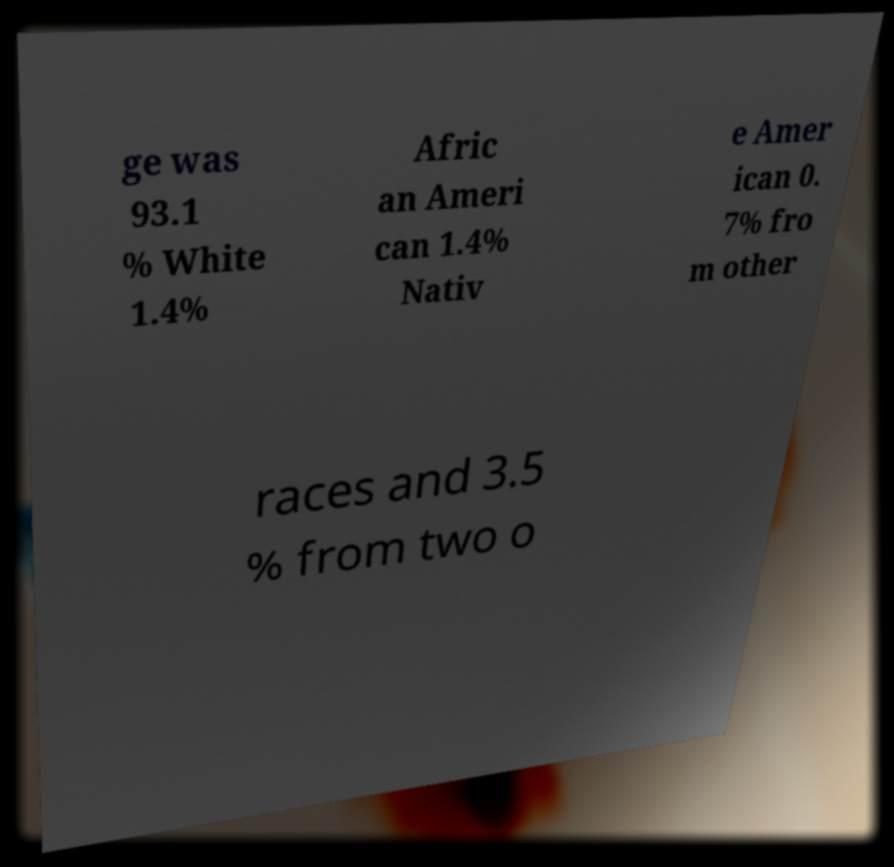I need the written content from this picture converted into text. Can you do that? ge was 93.1 % White 1.4% Afric an Ameri can 1.4% Nativ e Amer ican 0. 7% fro m other races and 3.5 % from two o 